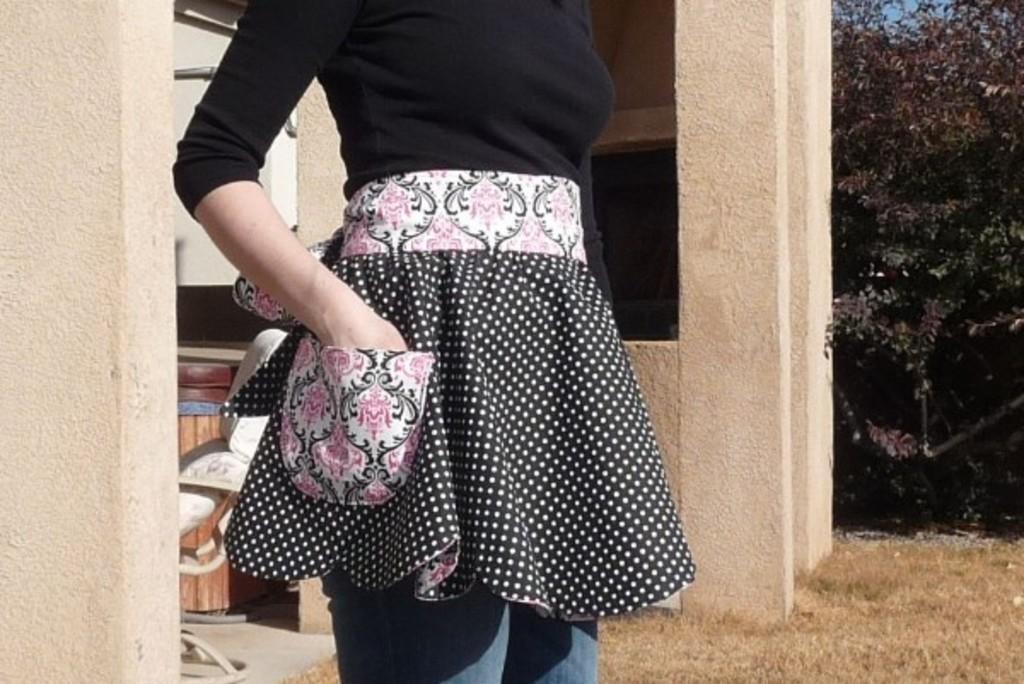Describe this image in one or two sentences. In this picture I can see a woman in the middle, in the background there are pillars, On the right side there are trees. 